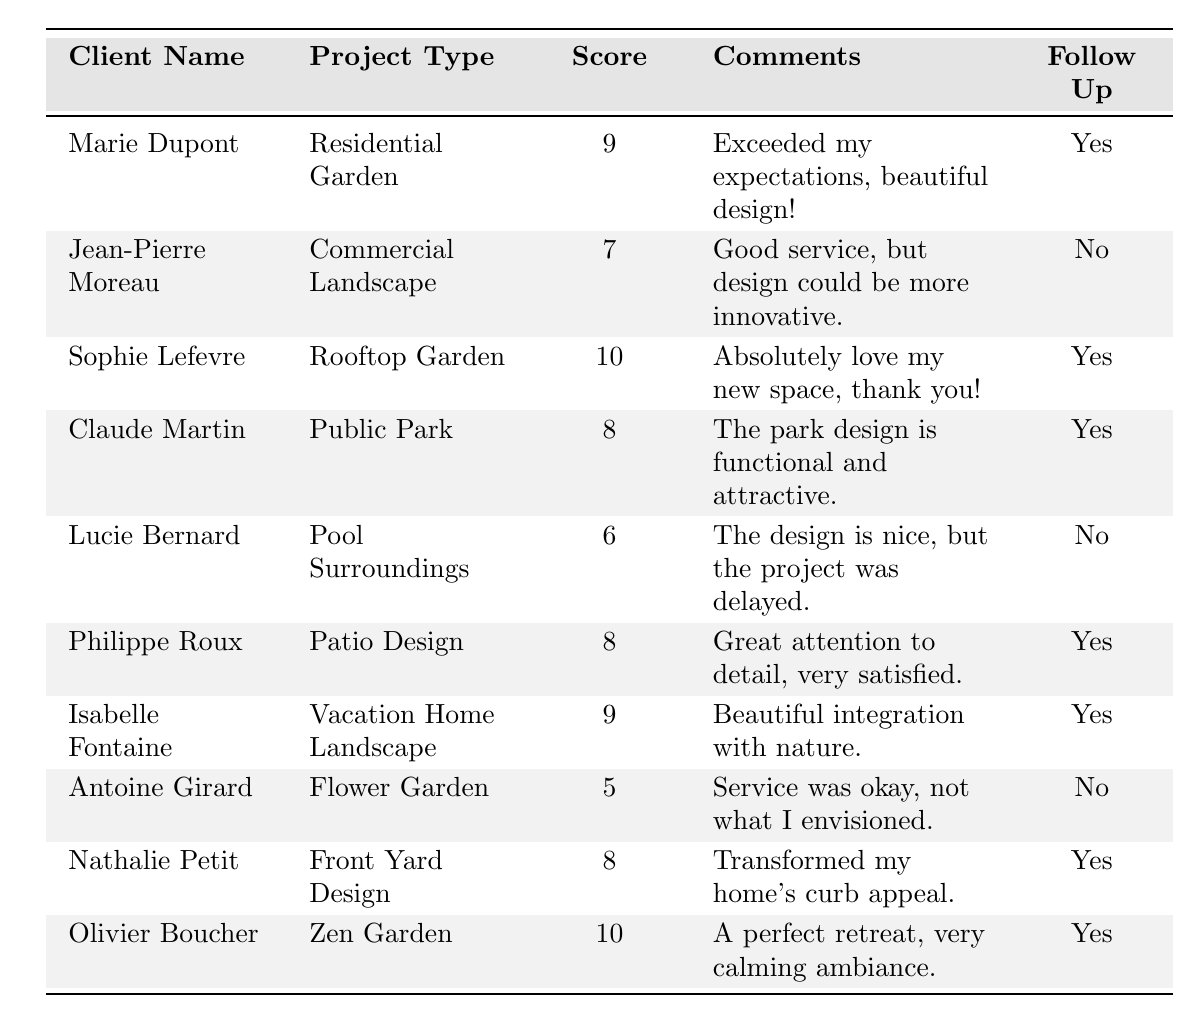What is the satisfaction score of Sophie Lefevre? Referring to the table, Sophie Lefevre has a satisfaction score listed as 10.
Answer: 10 How many clients expressed interest in follow-up? By scanning the "Follow Up" column, we see that Marie Dupont, Sophie Lefevre, Claude Martin, Philippe Roux, Isabelle Fontaine, Nathalie Petit, and Olivier Boucher indicated "Yes." This totals to 7 clients.
Answer: 7 What is the average satisfaction score for all clients? The scores are 9, 7, 10, 8, 6, 8, 9, 5, 8, 10. Summing these values gives 78. Since there are 10 clients, the average is 78/10 = 7.8.
Answer: 7.8 Which project type had the lowest satisfaction score? The scores range from 5 to 10. Antoine Girard, who worked on the Flower Garden, has the lowest score of 5.
Answer: Flower Garden Did any clients provide comments about the design being beautiful? Marie Dupont and Isabelle Fontaine both made comments indicating their designs were beautiful, as they mentioned "Exceeded my expectations, beautiful design!" and "Beautiful integration with nature."
Answer: Yes What is the difference in satisfaction scores between the highest and lowest scoring clients? The highest satisfaction score is 10 (Sophie Lefevre and Olivier Boucher) and the lowest is 5 (Antoine Girard). The difference is therefore 10 - 5 = 5.
Answer: 5 How many clients had a satisfaction score of 8 or higher? The clients with a score of 8 or higher are: Marie Dupont (9), Sophie Lefevre (10), Claude Martin (8), Philippe Roux (8), Isabelle Fontaine (9), Nathalie Petit (8), and Olivier Boucher (10). This sums to 7 clients.
Answer: 7 Which client had the highest satisfaction score, and what was their project type? The highest score of 10 belongs to both Sophie Lefevre and Olivier Boucher. Sophie worked on a Rooftop Garden and Olivier on a Zen Garden.
Answer: Sophie Lefevre, Rooftop Garden; Olivier Boucher, Zen Garden Are there more clients who expressed interest in a follow-up than those who did not? Counting the "Yes" follow-up responses (7) compared to "No" responses (3) shows that there are indeed more clients interested in follow-up.
Answer: Yes What was the average satisfaction score of clients who did not express interest in follow-up? The clients who did not express interest (Jean-Pierre Moreau, Lucie Bernard, Antoine Girard) have scores of 7, 6, and 5. The sum is 7 + 6 + 5 = 18. There are 3 clients, so the average is 18/3 = 6.
Answer: 6 Which project types received a satisfaction score of 10? The project types with a score of 10 are Rooftop Garden (Sophie Lefevre) and Zen Garden (Olivier Boucher).
Answer: Rooftop Garden, Zen Garden 